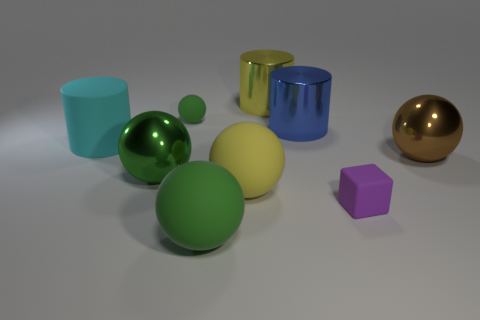The big thing to the left of the green shiny sphere has what shape?
Offer a very short reply. Cylinder. The rubber ball that is behind the big green metallic sphere that is behind the big yellow matte sphere is what color?
Your answer should be very brief. Green. Does the tiny rubber thing in front of the large yellow ball have the same shape as the big yellow thing that is behind the big blue metallic cylinder?
Provide a succinct answer. No. What is the shape of the blue metallic thing that is the same size as the yellow matte thing?
Offer a very short reply. Cylinder. What is the color of the small cube that is made of the same material as the large cyan thing?
Ensure brevity in your answer.  Purple. There is a yellow metal thing; is its shape the same as the big thing right of the tiny purple thing?
Your answer should be compact. No. There is another green object that is the same size as the green metallic object; what material is it?
Your answer should be compact. Rubber. Are there any other cylinders that have the same color as the rubber cylinder?
Provide a short and direct response. No. There is a object that is both right of the blue object and in front of the big green metallic sphere; what shape is it?
Make the answer very short. Cube. What number of purple things are made of the same material as the yellow cylinder?
Ensure brevity in your answer.  0. 